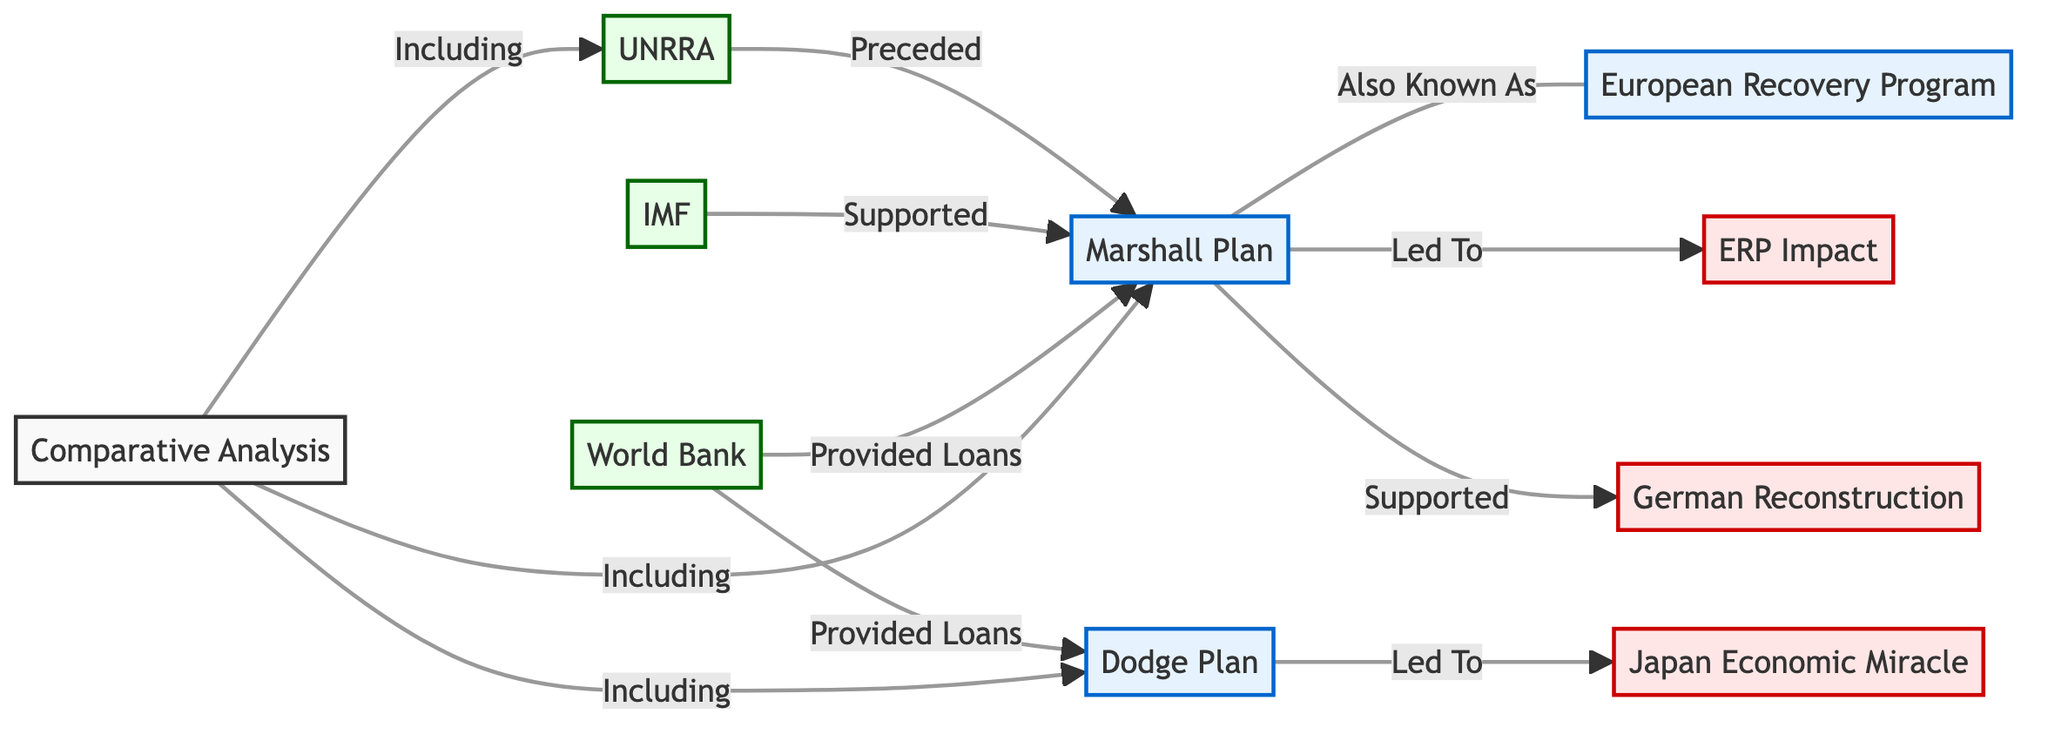What are the two plans compared in the diagram? The diagram directly lists the Marshall Plan and the Dodge Plan as the primary plans of focus, both shown as nodes in the flowchart.
Answer: Marshall Plan, Dodge Plan Which institution preceded the Marshall Plan? The diagram indicates a direct relationship between UNRRA and the Marshall Plan, marking UNRRA as having come before it.
Answer: UNRRA How many impacts are listed in the diagram? By counting the distinct impact nodes shown, there are three specified impacts resulting from the economic programs detailed in the diagram.
Answer: 3 What support did the IMF provide according to the diagram? The diagram specifies a direct relationship indicating that the IMF provided support to the Marshall Plan, which is directly stated in the flowchart connections.
Answer: Supported What was the result of the Dodge Plan according to the diagram? The Dodge Plan is shown to lead directly to the Japan Economic Miracle according to the flow established in the diagram.
Answer: Japan Economic Miracle How did the World Bank contribute to the plans illustrated? The flowchart outlines that the World Bank provided loans to both the Marshall Plan and the Dodge Plan, showing its role in supporting these programs.
Answer: Provided Loans Which recovery program is also known as the ERP? A direct connection indicates that the Marshall Plan is also referred to as the ERP, linking these two nodes together in the flowchart.
Answer: Marshall Plan What type of analysis is included in the comparison section of the diagram? The diagram indicates that the comparisons section includes multiple recovery plans, specifically mentioning the Marshall Plan and Dodge Plan as key components.
Answer: Comparative Analysis Which impact is associated with the Marshall Plan besides the ERP impact? The diagram shows that the Marshall Plan also supported German Reconstruction, illustrating a connection between these two nodes.
Answer: German Reconstruction 